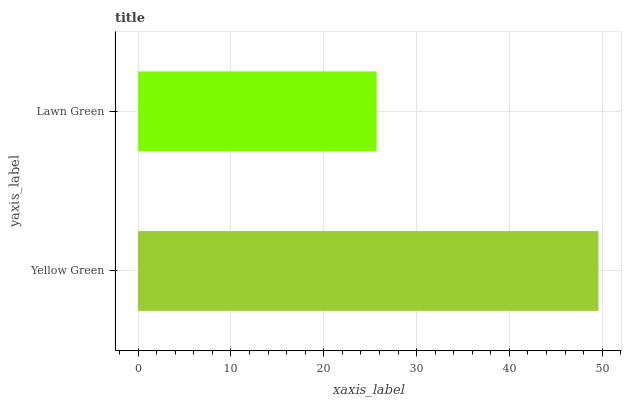Is Lawn Green the minimum?
Answer yes or no. Yes. Is Yellow Green the maximum?
Answer yes or no. Yes. Is Lawn Green the maximum?
Answer yes or no. No. Is Yellow Green greater than Lawn Green?
Answer yes or no. Yes. Is Lawn Green less than Yellow Green?
Answer yes or no. Yes. Is Lawn Green greater than Yellow Green?
Answer yes or no. No. Is Yellow Green less than Lawn Green?
Answer yes or no. No. Is Yellow Green the high median?
Answer yes or no. Yes. Is Lawn Green the low median?
Answer yes or no. Yes. Is Lawn Green the high median?
Answer yes or no. No. Is Yellow Green the low median?
Answer yes or no. No. 